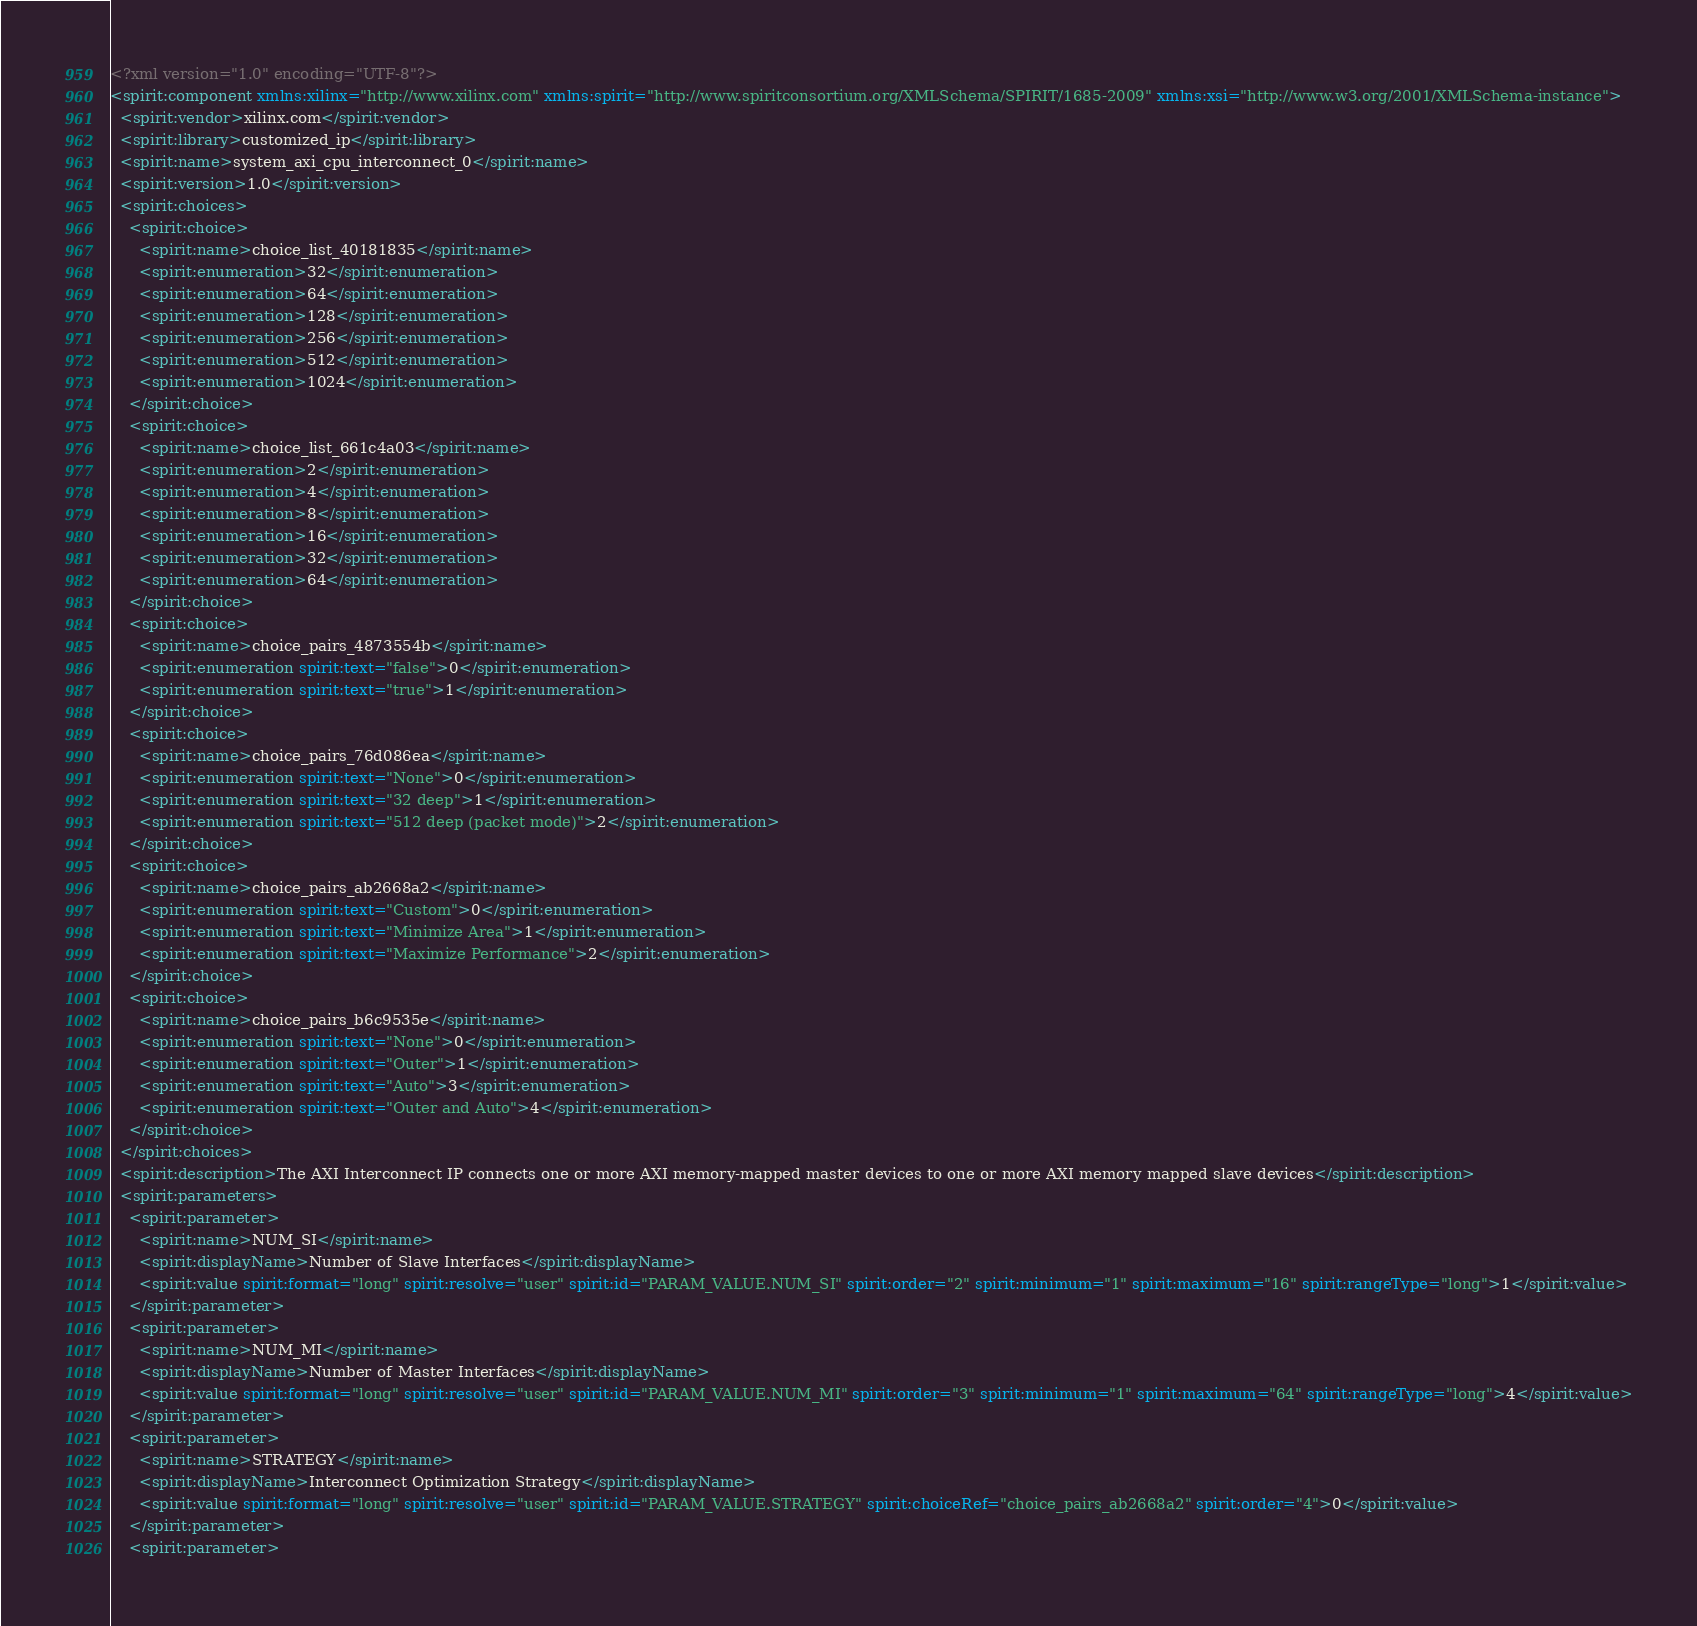Convert code to text. <code><loc_0><loc_0><loc_500><loc_500><_XML_><?xml version="1.0" encoding="UTF-8"?>
<spirit:component xmlns:xilinx="http://www.xilinx.com" xmlns:spirit="http://www.spiritconsortium.org/XMLSchema/SPIRIT/1685-2009" xmlns:xsi="http://www.w3.org/2001/XMLSchema-instance">
  <spirit:vendor>xilinx.com</spirit:vendor>
  <spirit:library>customized_ip</spirit:library>
  <spirit:name>system_axi_cpu_interconnect_0</spirit:name>
  <spirit:version>1.0</spirit:version>
  <spirit:choices>
    <spirit:choice>
      <spirit:name>choice_list_40181835</spirit:name>
      <spirit:enumeration>32</spirit:enumeration>
      <spirit:enumeration>64</spirit:enumeration>
      <spirit:enumeration>128</spirit:enumeration>
      <spirit:enumeration>256</spirit:enumeration>
      <spirit:enumeration>512</spirit:enumeration>
      <spirit:enumeration>1024</spirit:enumeration>
    </spirit:choice>
    <spirit:choice>
      <spirit:name>choice_list_661c4a03</spirit:name>
      <spirit:enumeration>2</spirit:enumeration>
      <spirit:enumeration>4</spirit:enumeration>
      <spirit:enumeration>8</spirit:enumeration>
      <spirit:enumeration>16</spirit:enumeration>
      <spirit:enumeration>32</spirit:enumeration>
      <spirit:enumeration>64</spirit:enumeration>
    </spirit:choice>
    <spirit:choice>
      <spirit:name>choice_pairs_4873554b</spirit:name>
      <spirit:enumeration spirit:text="false">0</spirit:enumeration>
      <spirit:enumeration spirit:text="true">1</spirit:enumeration>
    </spirit:choice>
    <spirit:choice>
      <spirit:name>choice_pairs_76d086ea</spirit:name>
      <spirit:enumeration spirit:text="None">0</spirit:enumeration>
      <spirit:enumeration spirit:text="32 deep">1</spirit:enumeration>
      <spirit:enumeration spirit:text="512 deep (packet mode)">2</spirit:enumeration>
    </spirit:choice>
    <spirit:choice>
      <spirit:name>choice_pairs_ab2668a2</spirit:name>
      <spirit:enumeration spirit:text="Custom">0</spirit:enumeration>
      <spirit:enumeration spirit:text="Minimize Area">1</spirit:enumeration>
      <spirit:enumeration spirit:text="Maximize Performance">2</spirit:enumeration>
    </spirit:choice>
    <spirit:choice>
      <spirit:name>choice_pairs_b6c9535e</spirit:name>
      <spirit:enumeration spirit:text="None">0</spirit:enumeration>
      <spirit:enumeration spirit:text="Outer">1</spirit:enumeration>
      <spirit:enumeration spirit:text="Auto">3</spirit:enumeration>
      <spirit:enumeration spirit:text="Outer and Auto">4</spirit:enumeration>
    </spirit:choice>
  </spirit:choices>
  <spirit:description>The AXI Interconnect IP connects one or more AXI memory-mapped master devices to one or more AXI memory mapped slave devices</spirit:description>
  <spirit:parameters>
    <spirit:parameter>
      <spirit:name>NUM_SI</spirit:name>
      <spirit:displayName>Number of Slave Interfaces</spirit:displayName>
      <spirit:value spirit:format="long" spirit:resolve="user" spirit:id="PARAM_VALUE.NUM_SI" spirit:order="2" spirit:minimum="1" spirit:maximum="16" spirit:rangeType="long">1</spirit:value>
    </spirit:parameter>
    <spirit:parameter>
      <spirit:name>NUM_MI</spirit:name>
      <spirit:displayName>Number of Master Interfaces</spirit:displayName>
      <spirit:value spirit:format="long" spirit:resolve="user" spirit:id="PARAM_VALUE.NUM_MI" spirit:order="3" spirit:minimum="1" spirit:maximum="64" spirit:rangeType="long">4</spirit:value>
    </spirit:parameter>
    <spirit:parameter>
      <spirit:name>STRATEGY</spirit:name>
      <spirit:displayName>Interconnect Optimization Strategy</spirit:displayName>
      <spirit:value spirit:format="long" spirit:resolve="user" spirit:id="PARAM_VALUE.STRATEGY" spirit:choiceRef="choice_pairs_ab2668a2" spirit:order="4">0</spirit:value>
    </spirit:parameter>
    <spirit:parameter></code> 